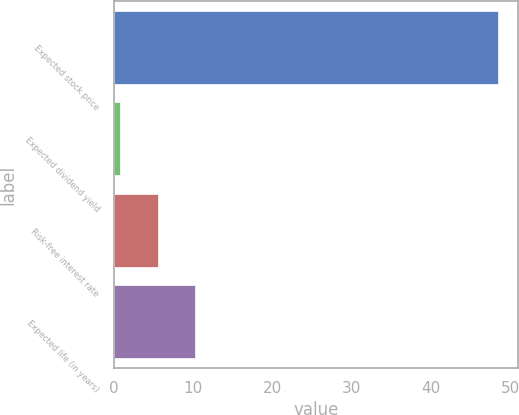<chart> <loc_0><loc_0><loc_500><loc_500><bar_chart><fcel>Expected stock price<fcel>Expected dividend yield<fcel>Risk-free interest rate<fcel>Expected life (in years)<nl><fcel>48.5<fcel>0.75<fcel>5.53<fcel>10.3<nl></chart> 